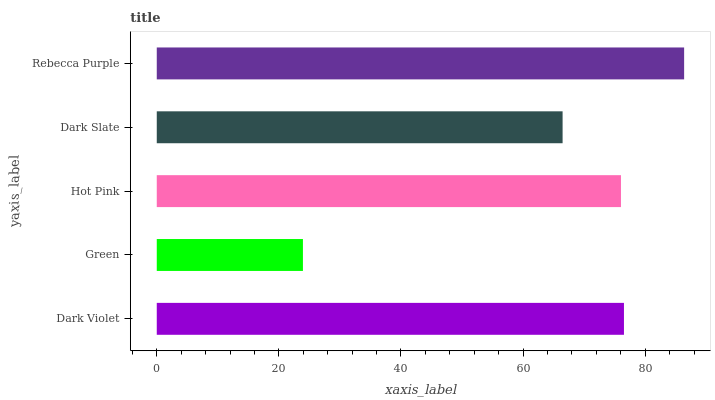Is Green the minimum?
Answer yes or no. Yes. Is Rebecca Purple the maximum?
Answer yes or no. Yes. Is Hot Pink the minimum?
Answer yes or no. No. Is Hot Pink the maximum?
Answer yes or no. No. Is Hot Pink greater than Green?
Answer yes or no. Yes. Is Green less than Hot Pink?
Answer yes or no. Yes. Is Green greater than Hot Pink?
Answer yes or no. No. Is Hot Pink less than Green?
Answer yes or no. No. Is Hot Pink the high median?
Answer yes or no. Yes. Is Hot Pink the low median?
Answer yes or no. Yes. Is Green the high median?
Answer yes or no. No. Is Dark Violet the low median?
Answer yes or no. No. 